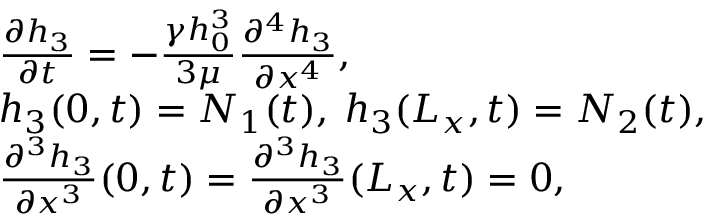Convert formula to latex. <formula><loc_0><loc_0><loc_500><loc_500>\begin{array} { r l } & { \frac { \partial h _ { 3 } } { \partial t } = - \frac { \gamma h _ { 0 } ^ { 3 } } { 3 \mu } \frac { \partial ^ { 4 } h _ { 3 } } { \partial x ^ { 4 } } , } \\ & { h _ { 3 } ( 0 , t ) = N _ { 1 } ( t ) , \, h _ { 3 } ( L _ { x } , t ) = N _ { 2 } ( t ) , } \\ & { \frac { \partial ^ { 3 } h _ { 3 } } { \partial x ^ { 3 } } ( 0 , t ) = \frac { \partial ^ { 3 } h _ { 3 } } { \partial x ^ { 3 } } ( L _ { x } , t ) = 0 , } \end{array}</formula> 